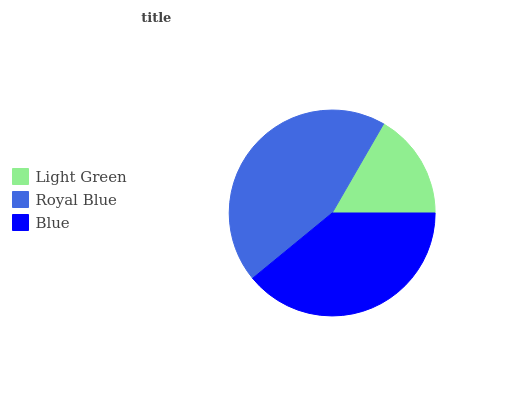Is Light Green the minimum?
Answer yes or no. Yes. Is Royal Blue the maximum?
Answer yes or no. Yes. Is Blue the minimum?
Answer yes or no. No. Is Blue the maximum?
Answer yes or no. No. Is Royal Blue greater than Blue?
Answer yes or no. Yes. Is Blue less than Royal Blue?
Answer yes or no. Yes. Is Blue greater than Royal Blue?
Answer yes or no. No. Is Royal Blue less than Blue?
Answer yes or no. No. Is Blue the high median?
Answer yes or no. Yes. Is Blue the low median?
Answer yes or no. Yes. Is Royal Blue the high median?
Answer yes or no. No. Is Light Green the low median?
Answer yes or no. No. 